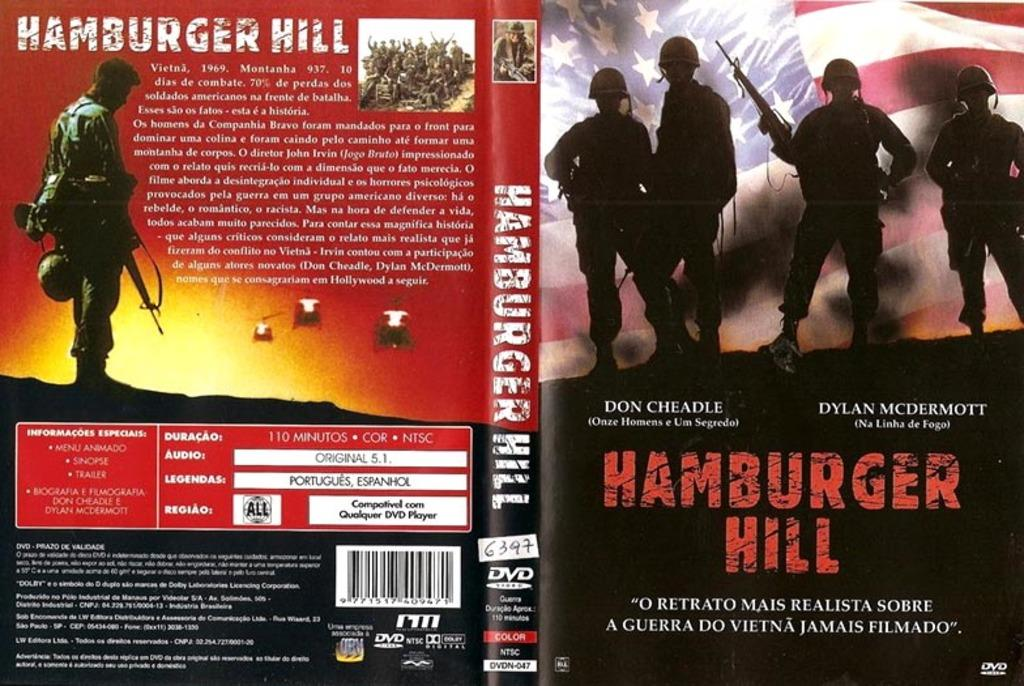<image>
Offer a succinct explanation of the picture presented. The front and back cover of a book called Hamburger Hill. 